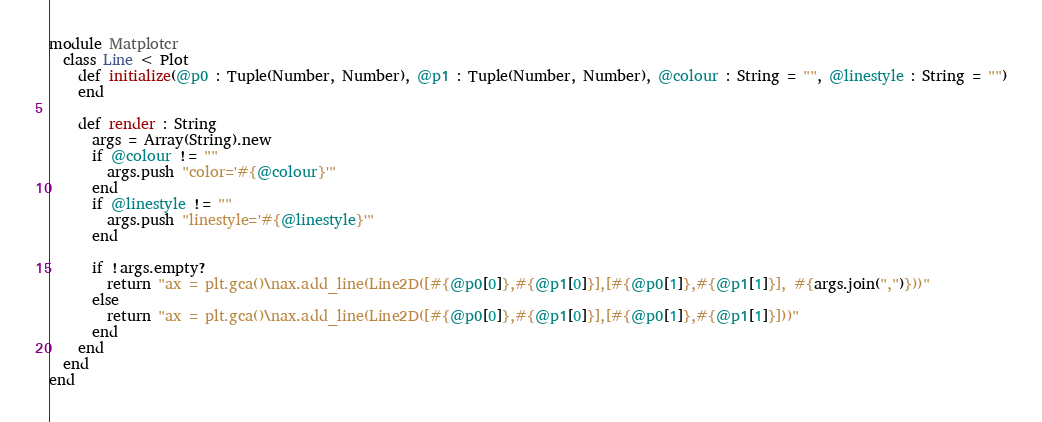Convert code to text. <code><loc_0><loc_0><loc_500><loc_500><_Crystal_>
module Matplotcr
  class Line < Plot
    def initialize(@p0 : Tuple(Number, Number), @p1 : Tuple(Number, Number), @colour : String = "", @linestyle : String = "")
    end

    def render : String
      args = Array(String).new
      if @colour != ""
        args.push "color='#{@colour}'"
      end
      if @linestyle != ""
        args.push "linestyle='#{@linestyle}'"
      end

      if !args.empty?
        return "ax = plt.gca()\nax.add_line(Line2D([#{@p0[0]},#{@p1[0]}],[#{@p0[1]},#{@p1[1]}], #{args.join(",")}))"
      else
        return "ax = plt.gca()\nax.add_line(Line2D([#{@p0[0]},#{@p1[0]}],[#{@p0[1]},#{@p1[1]}]))"
      end
    end
  end
end
</code> 